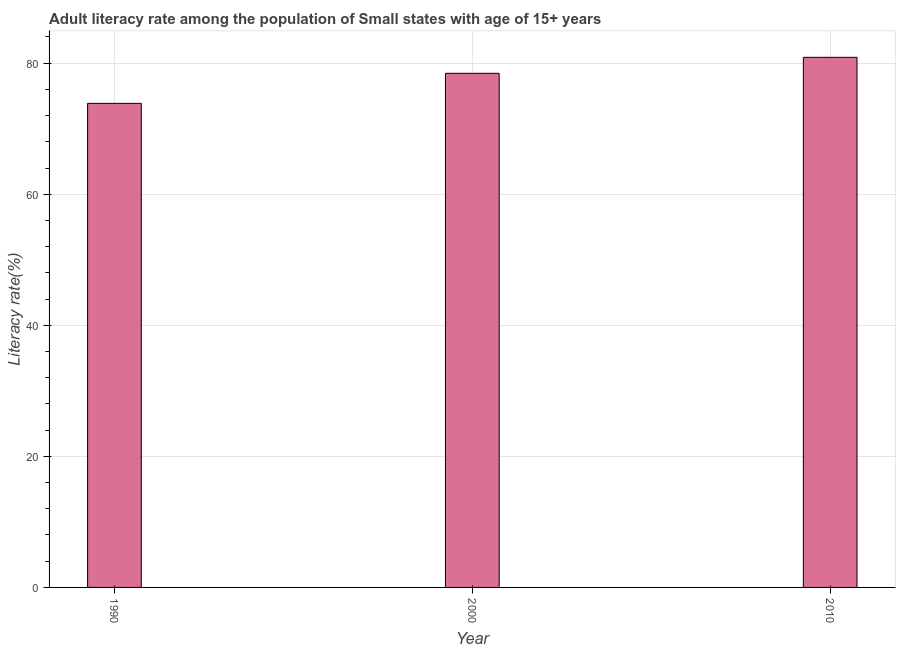Does the graph contain any zero values?
Provide a short and direct response. No. Does the graph contain grids?
Your answer should be very brief. Yes. What is the title of the graph?
Keep it short and to the point. Adult literacy rate among the population of Small states with age of 15+ years. What is the label or title of the Y-axis?
Make the answer very short. Literacy rate(%). What is the adult literacy rate in 2000?
Ensure brevity in your answer.  78.45. Across all years, what is the maximum adult literacy rate?
Offer a terse response. 80.89. Across all years, what is the minimum adult literacy rate?
Ensure brevity in your answer.  73.86. What is the sum of the adult literacy rate?
Provide a short and direct response. 233.21. What is the difference between the adult literacy rate in 1990 and 2010?
Your response must be concise. -7.03. What is the average adult literacy rate per year?
Give a very brief answer. 77.73. What is the median adult literacy rate?
Provide a short and direct response. 78.45. What is the ratio of the adult literacy rate in 1990 to that in 2000?
Offer a very short reply. 0.94. Is the adult literacy rate in 1990 less than that in 2010?
Offer a very short reply. Yes. Is the difference between the adult literacy rate in 2000 and 2010 greater than the difference between any two years?
Offer a terse response. No. What is the difference between the highest and the second highest adult literacy rate?
Your answer should be compact. 2.44. What is the difference between the highest and the lowest adult literacy rate?
Make the answer very short. 7.03. Are all the bars in the graph horizontal?
Keep it short and to the point. No. Are the values on the major ticks of Y-axis written in scientific E-notation?
Keep it short and to the point. No. What is the Literacy rate(%) of 1990?
Keep it short and to the point. 73.86. What is the Literacy rate(%) in 2000?
Your answer should be compact. 78.45. What is the Literacy rate(%) in 2010?
Your response must be concise. 80.89. What is the difference between the Literacy rate(%) in 1990 and 2000?
Your answer should be compact. -4.59. What is the difference between the Literacy rate(%) in 1990 and 2010?
Provide a succinct answer. -7.03. What is the difference between the Literacy rate(%) in 2000 and 2010?
Your answer should be compact. -2.44. What is the ratio of the Literacy rate(%) in 1990 to that in 2000?
Ensure brevity in your answer.  0.94. What is the ratio of the Literacy rate(%) in 1990 to that in 2010?
Ensure brevity in your answer.  0.91. 